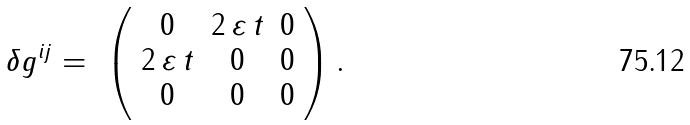Convert formula to latex. <formula><loc_0><loc_0><loc_500><loc_500>\delta g ^ { i j } = \ \left ( \begin{array} { c c c } 0 & 2 \, \varepsilon \, t & 0 \\ 2 \, \varepsilon \, t & 0 & 0 \\ 0 & 0 & 0 \end{array} \right ) .</formula> 